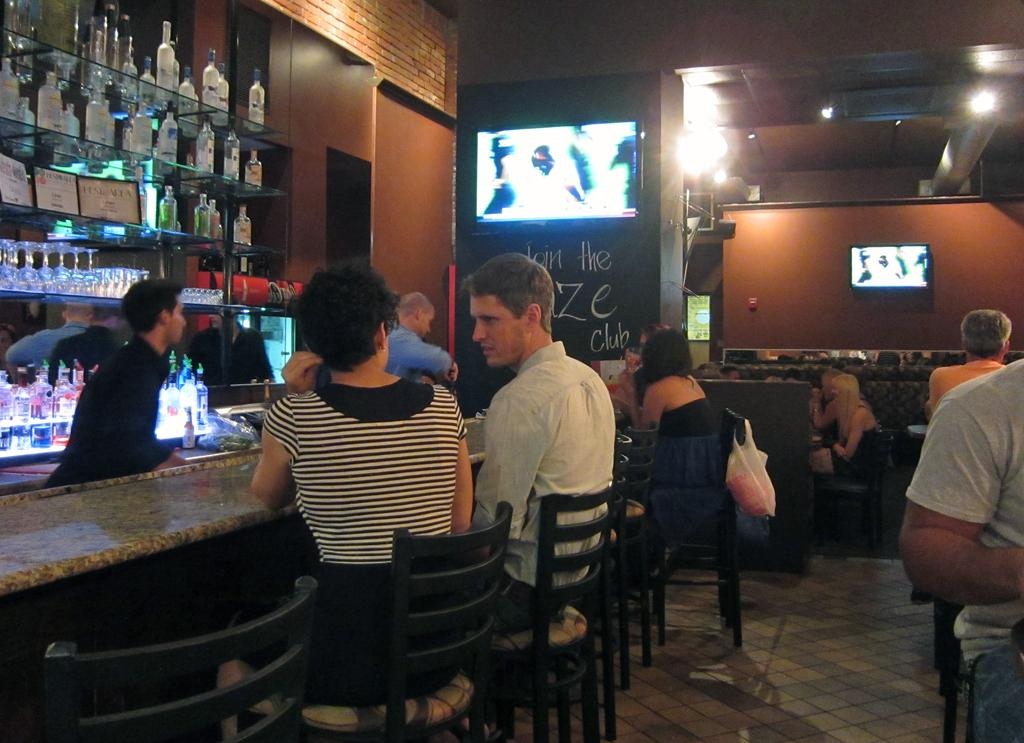What is the main object in the image? There is a rack in the image. What items can be found on the rack? The rack contains bottles, a television, chairs, and a table. What are the people in the image doing? There are people sitting on the chairs. What type of baseball can be seen on the rack in the image? There is no baseball present in the image; the rack contains bottles, a television, chairs, and a table. What kind of leather is covering the chairs in the image? The provided facts do not mention the material of the chairs, so it cannot be determined from the image. 